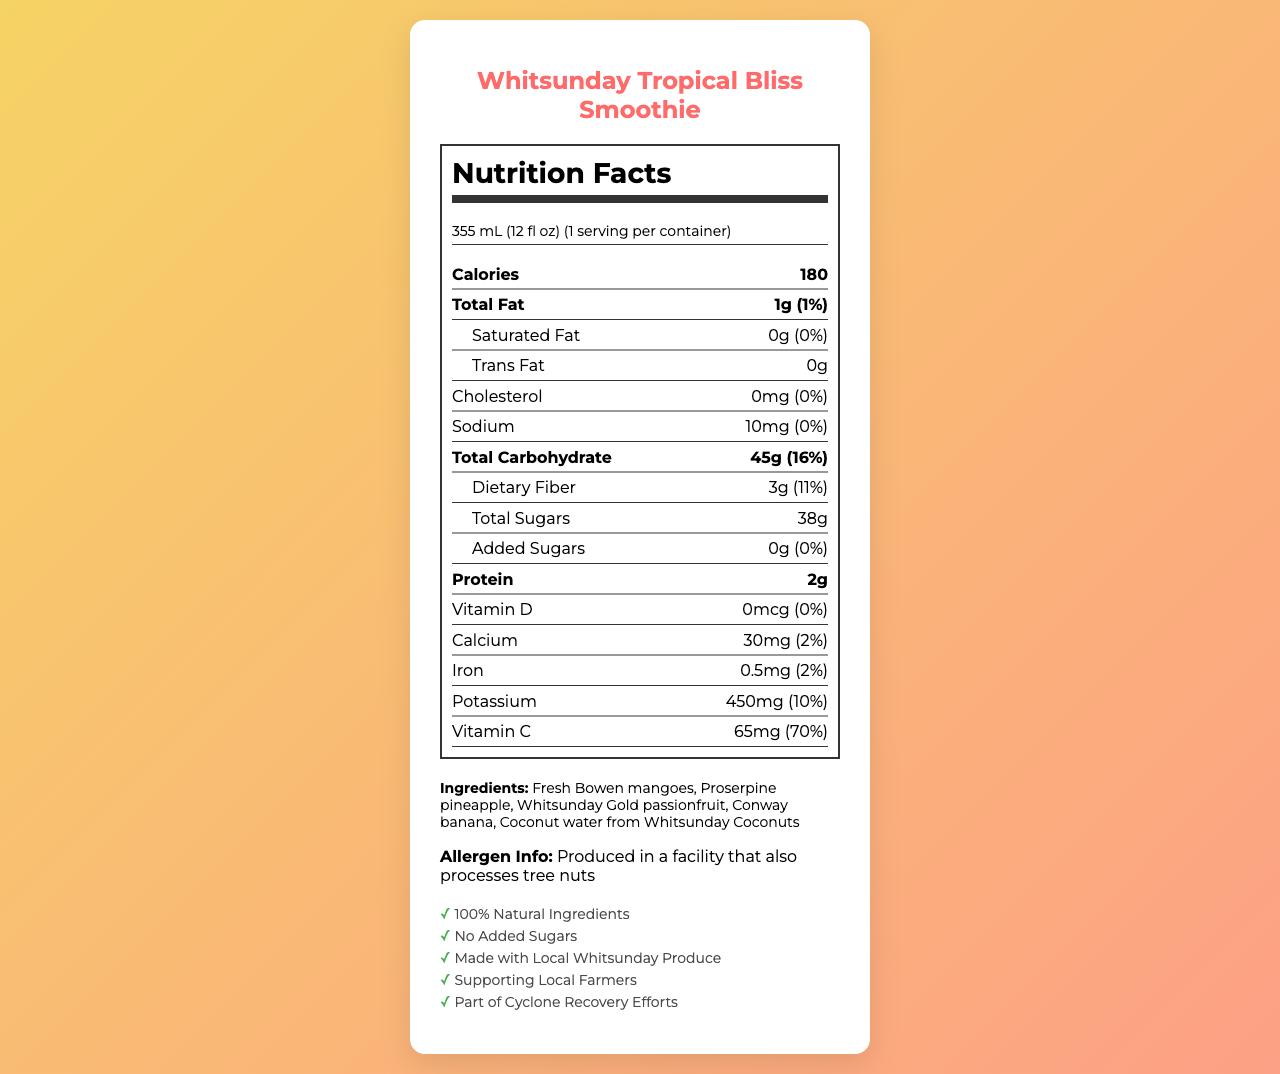what is the serving size of the smoothie? The serving size is listed directly under the product name and serving information in the document.
Answer: 355 mL (12 fl oz) how many calories are in one serving of the smoothie? The calorie content is prominently displayed in the Nutrition Facts section.
Answer: 180 how much total fat does one serving contain? Total fat content is listed under the Nutrition Facts section.
Answer: 1g What percentage of the daily value of dietary fiber does one serving provide? The daily value percentage of dietary fiber is listed beside its amount in grams.
Answer: 11% Which mineral has the highest percentage of daily value in the smoothie? A. Calcium B. Iron C. Potassium D. Sodium The potassium content has a daily value of 10%, which is the highest among the listed minerals.
Answer: C. Potassium how much vitamin C is in one serving of the smoothie? The amount of vitamin C is listed under the Nutrition Facts section.
Answer: 65mg What is the total amount of sugars in one serving? The total sugars are listed under the Total Carbohydrate section in the Nutrition Facts.
Answer: 38g Is there any added sugar in the smoothie? The document indicates that the amount of added sugars is 0g and the additional info states "No Added Sugars".
Answer: No Does the smoothie contain saturated fat? The saturated fat content is listed as 0g in the Nutrition Facts section.
Answer: No Does the smoothie contain any allergens? If so, what are they? The allergen information at the bottom of the document notes that the smoothie is produced in a facility that also processes tree nuts.
Answer: Yes, tree nuts what kind of produce is used in the smoothie? The ingredients are listed in the document under the ingredients section.
Answer: Fresh Bowen mangoes, Proserpine pineapple, Whitsunday Gold passionfruit, Conway banana, Coconut water from Whitsunday Coconuts Where are the ingredients sourced from? A. Imported B. Local to the Whitsunday Region C. Mixed sources The additional info states that the ingredients are "Made with Local Whitsunday Produce."
Answer: B. Local to the Whitsunday Region Is the smoothie part of any special initiatives? The additional info section mentions that the smoothie is part of cyclone recovery efforts.
Answer: Yes What is the main idea of the document? The document includes nutritional data, ingredient sourcing, allergen info, and additional benefits related to community support.
Answer: The main idea of the document is to provide detailed nutritional information about the Whitsunday Tropical Bliss Smoothie, highlighting its natural ingredients sourced from the Whitsunday Region and its contribution to local cyclone recovery efforts. Does the smoothie contain any vitamin D? The amount of vitamin D is listed as 0mcg on the Nutrition Facts Label.
Answer: No Which vitamin is most abundant in the Whitsunday Tropical Bliss Smoothie? A. Vitamin D B. Vitamin C C. Calcium D. Iron The vitamin C content is 65mg, which provides 70% of the daily value, the highest percentage among the listed vitamins and minerals.
Answer: B. Vitamin C Can you determine the exact amount of coconut water used in the smoothie? The document lists coconut water as an ingredient but does not specify the exact amount used.
Answer: No 